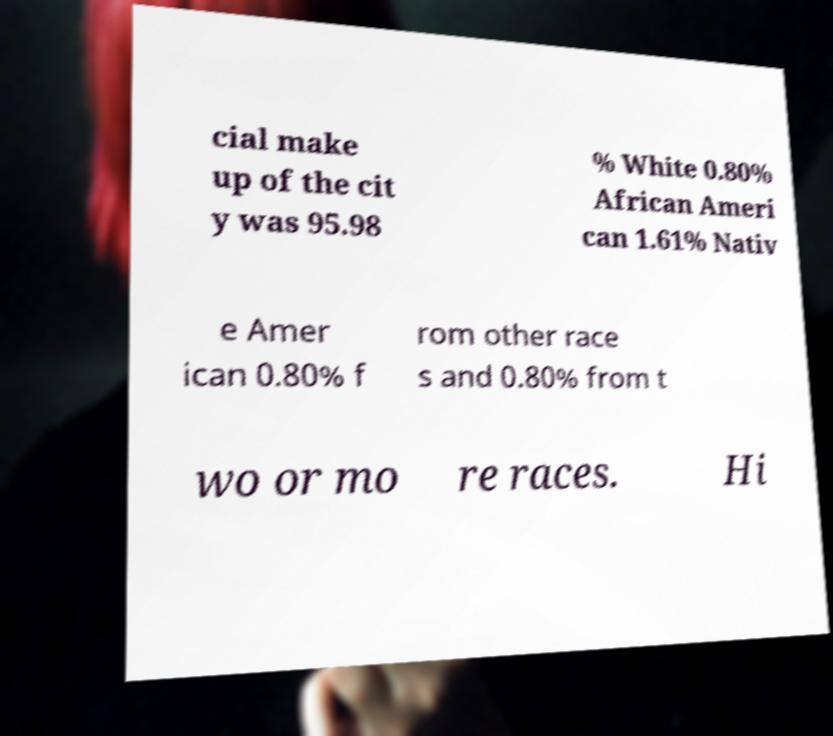Please read and relay the text visible in this image. What does it say? cial make up of the cit y was 95.98 % White 0.80% African Ameri can 1.61% Nativ e Amer ican 0.80% f rom other race s and 0.80% from t wo or mo re races. Hi 